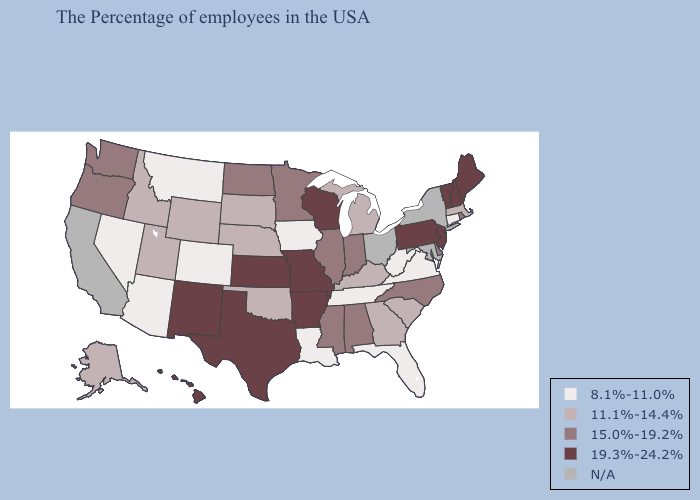What is the value of Hawaii?
Answer briefly. 19.3%-24.2%. Name the states that have a value in the range N/A?
Answer briefly. New York, Maryland, Ohio, California. Name the states that have a value in the range N/A?
Quick response, please. New York, Maryland, Ohio, California. Name the states that have a value in the range 15.0%-19.2%?
Write a very short answer. Rhode Island, Delaware, North Carolina, Indiana, Alabama, Illinois, Mississippi, Minnesota, North Dakota, Washington, Oregon. Name the states that have a value in the range 8.1%-11.0%?
Answer briefly. Connecticut, Virginia, West Virginia, Florida, Tennessee, Louisiana, Iowa, Colorado, Montana, Arizona, Nevada. Among the states that border New Mexico , which have the lowest value?
Keep it brief. Colorado, Arizona. What is the value of Utah?
Be succinct. 11.1%-14.4%. What is the highest value in states that border Wyoming?
Be succinct. 11.1%-14.4%. What is the value of Wisconsin?
Short answer required. 19.3%-24.2%. What is the highest value in the South ?
Give a very brief answer. 19.3%-24.2%. Among the states that border Minnesota , does North Dakota have the lowest value?
Short answer required. No. What is the value of New Hampshire?
Answer briefly. 19.3%-24.2%. Which states have the highest value in the USA?
Concise answer only. Maine, New Hampshire, Vermont, New Jersey, Pennsylvania, Wisconsin, Missouri, Arkansas, Kansas, Texas, New Mexico, Hawaii. Among the states that border South Carolina , does Georgia have the highest value?
Quick response, please. No. What is the lowest value in the MidWest?
Be succinct. 8.1%-11.0%. 